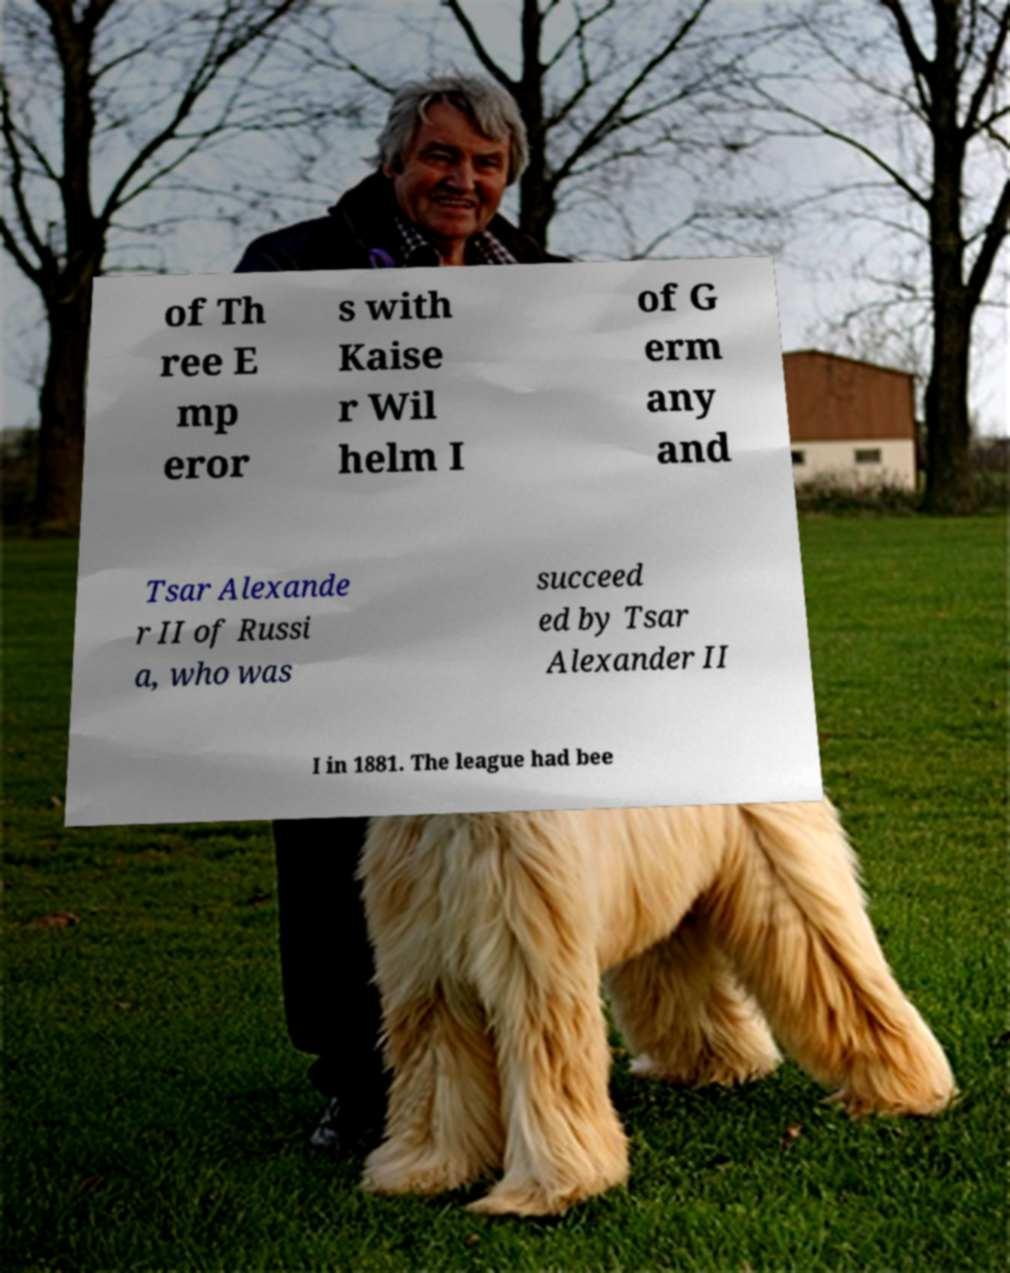Could you extract and type out the text from this image? of Th ree E mp eror s with Kaise r Wil helm I of G erm any and Tsar Alexande r II of Russi a, who was succeed ed by Tsar Alexander II I in 1881. The league had bee 